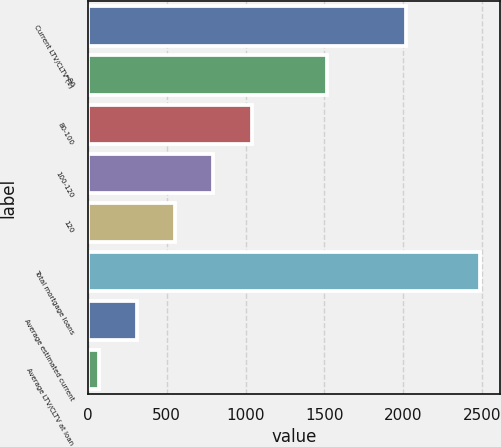Convert chart to OTSL. <chart><loc_0><loc_0><loc_500><loc_500><bar_chart><fcel>Current LTV/CLTV (1)<fcel>=80<fcel>80-100<fcel>100-120<fcel>120<fcel>Total mortgage loans<fcel>Average estimated current<fcel>Average LTV/CLTV at loan<nl><fcel>2015<fcel>1519<fcel>1037.8<fcel>796.1<fcel>554.4<fcel>2488<fcel>312.7<fcel>71<nl></chart> 